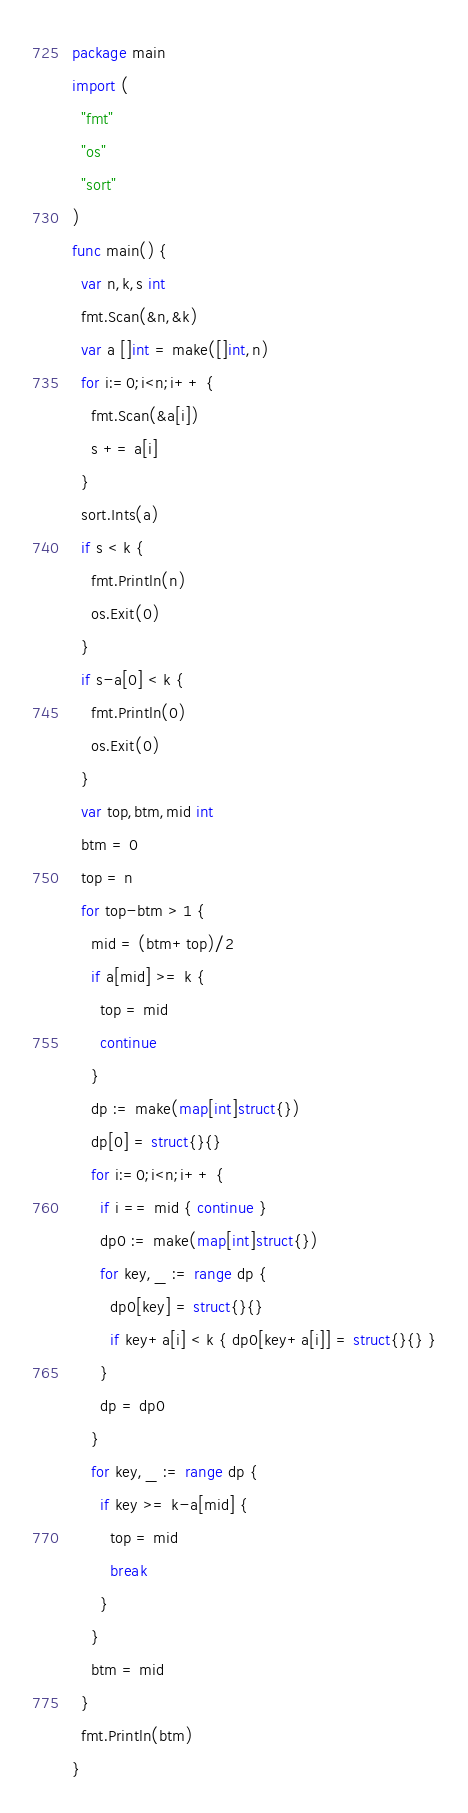<code> <loc_0><loc_0><loc_500><loc_500><_Go_>package main
import (
  "fmt"
  "os"
  "sort"
)
func main() {
  var n,k,s int
  fmt.Scan(&n,&k)
  var a []int = make([]int,n)
  for i:=0;i<n;i++ {
    fmt.Scan(&a[i])
    s += a[i]
  }
  sort.Ints(a)
  if s < k {
    fmt.Println(n)
    os.Exit(0)
  }
  if s-a[0] < k {
    fmt.Println(0)
    os.Exit(0)
  }
  var top,btm,mid int
  btm = 0
  top = n
  for top-btm > 1 {
    mid = (btm+top)/2
    if a[mid] >= k {
      top = mid
      continue
    }
    dp := make(map[int]struct{})
    dp[0] = struct{}{}
    for i:=0;i<n;i++ {
      if i == mid { continue }
      dp0 := make(map[int]struct{})
      for key,_ := range dp {
        dp0[key] = struct{}{}
        if key+a[i] < k { dp0[key+a[i]] = struct{}{} }
      }
      dp = dp0
    }
    for key,_ := range dp {
      if key >= k-a[mid] {
        top = mid
        break
      }
    }
    btm = mid
  }
  fmt.Println(btm)
}</code> 